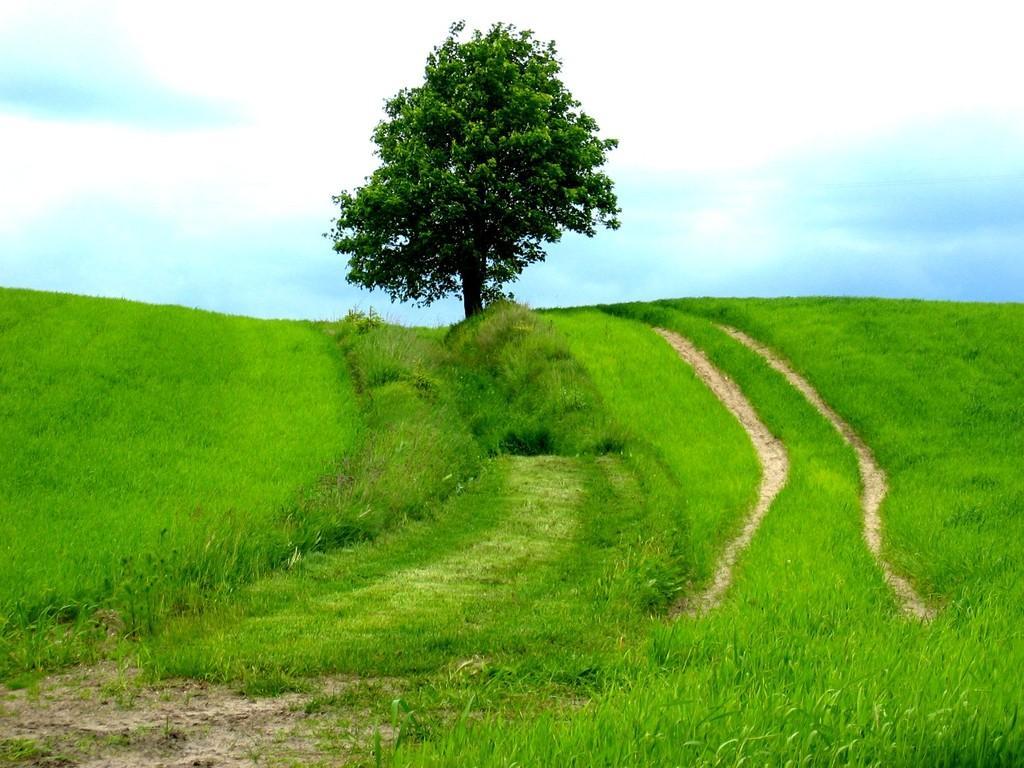Describe this image in one or two sentences. In this image I can see the ground, some grass on the ground which is green in color and a tree. In the background I can see the sky. 